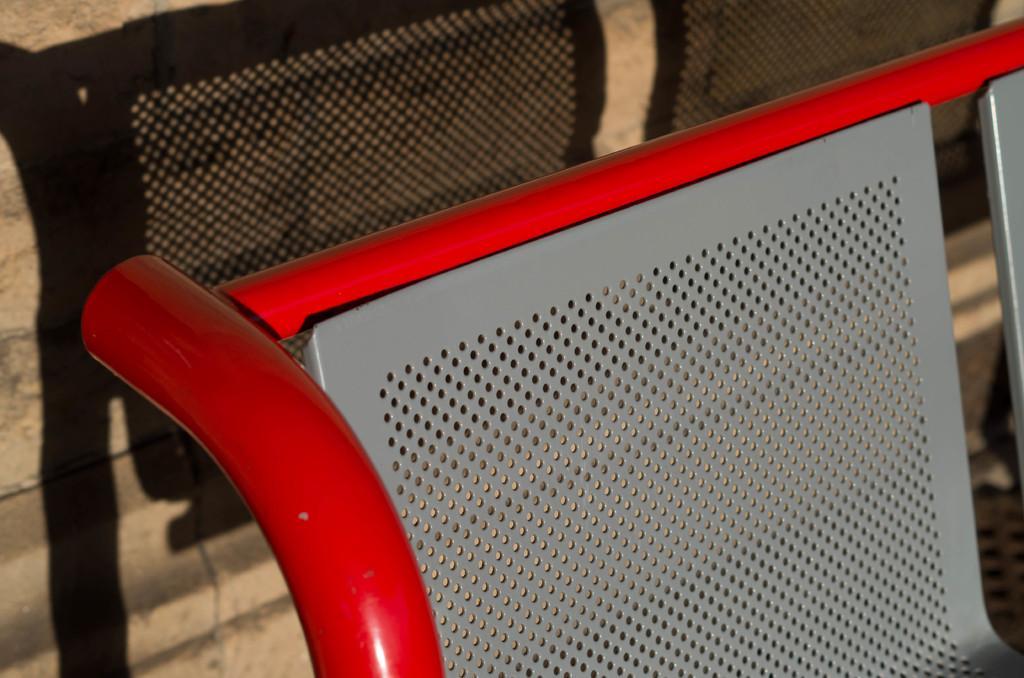Please provide a concise description of this image. In this picture, we see an iron chair which is in grey and red color. Behind that, we see a wall which is made up of stones and we even see the shadow of that chair. 